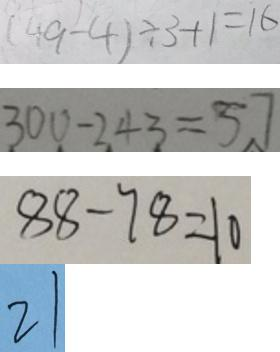<formula> <loc_0><loc_0><loc_500><loc_500>( 4 9 - 4 ) \div 3 + 1 = 1 6 
 3 0 0 - 2 4 3 = 5 7 
 8 8 - 7 8 = 1 0 
 2 1</formula> 